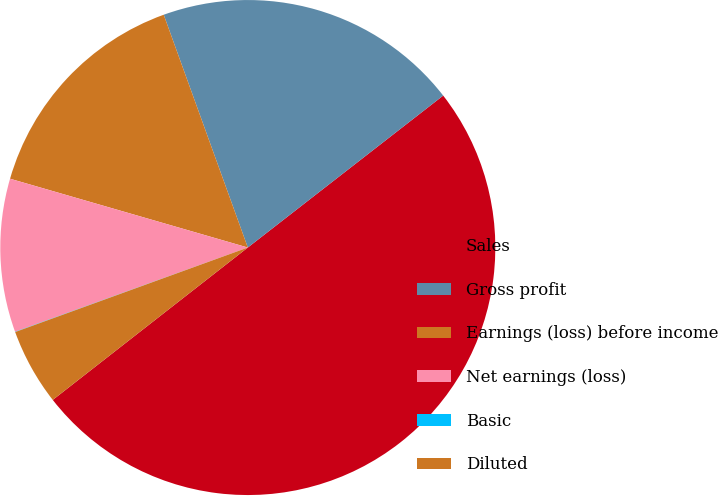Convert chart. <chart><loc_0><loc_0><loc_500><loc_500><pie_chart><fcel>Sales<fcel>Gross profit<fcel>Earnings (loss) before income<fcel>Net earnings (loss)<fcel>Basic<fcel>Diluted<nl><fcel>49.97%<fcel>20.0%<fcel>15.0%<fcel>10.01%<fcel>0.02%<fcel>5.01%<nl></chart> 